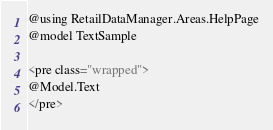Convert code to text. <code><loc_0><loc_0><loc_500><loc_500><_C#_>@using RetailDataManager.Areas.HelpPage
@model TextSample

<pre class="wrapped">
@Model.Text
</pre></code> 